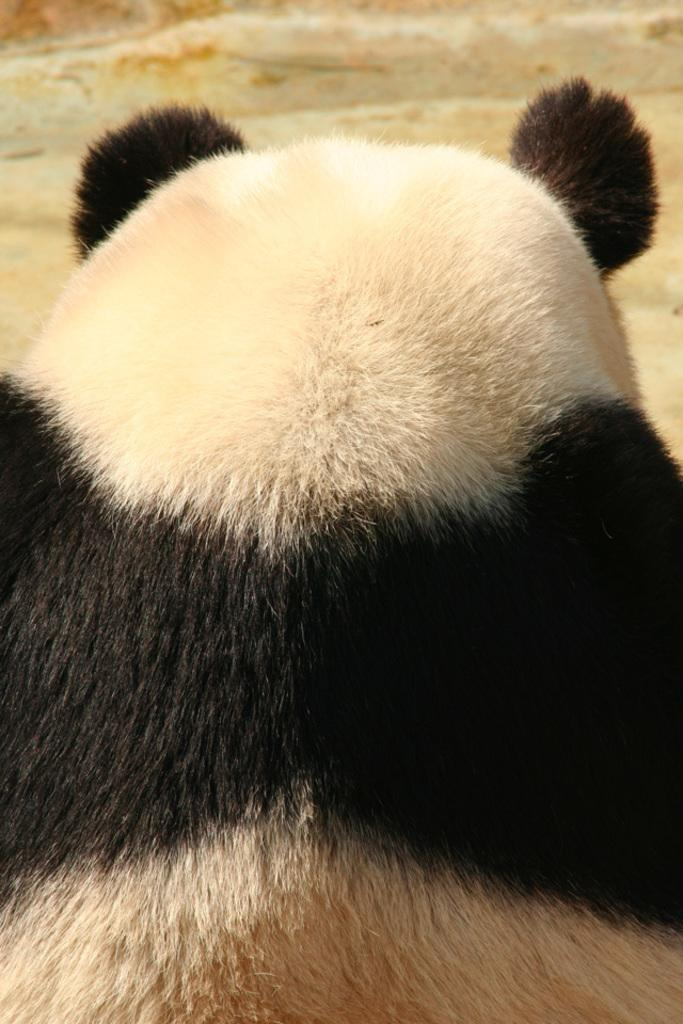What is the main subject of the picture? The main subject of the picture is a panda. Where is the panda located in the image? The panda is in the middle of the picture. Can you describe the background of the image? The background of the image is blurred. What type of shelf can be seen in the background of the image? There is no shelf present in the image; the background is blurred. Is there any sleet visible in the image? There is no sleet present in the image; it features a panda in the middle of the picture with a blurred background. 